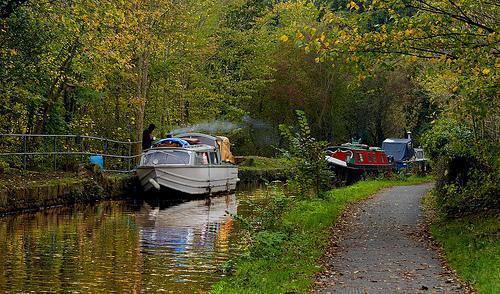How many people in the picture?
Give a very brief answer. 1. 